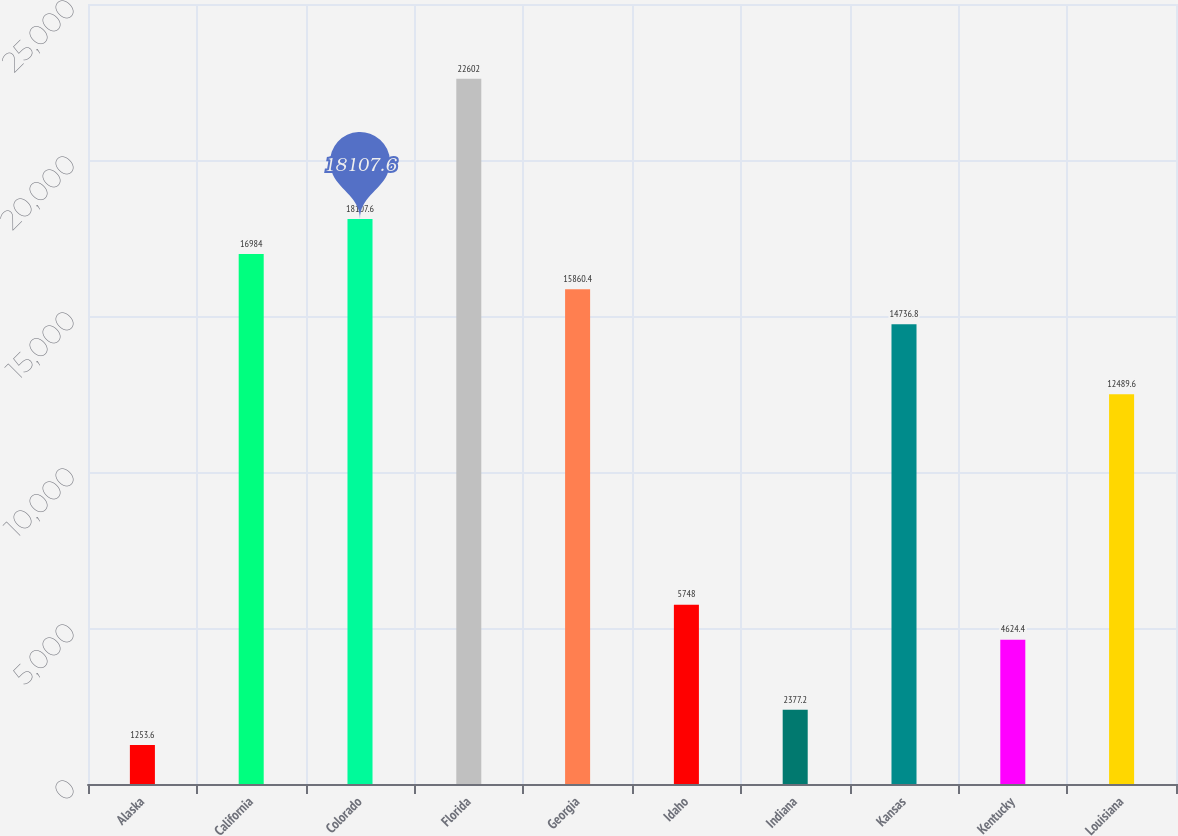Convert chart. <chart><loc_0><loc_0><loc_500><loc_500><bar_chart><fcel>Alaska<fcel>California<fcel>Colorado<fcel>Florida<fcel>Georgia<fcel>Idaho<fcel>Indiana<fcel>Kansas<fcel>Kentucky<fcel>Louisiana<nl><fcel>1253.6<fcel>16984<fcel>18107.6<fcel>22602<fcel>15860.4<fcel>5748<fcel>2377.2<fcel>14736.8<fcel>4624.4<fcel>12489.6<nl></chart> 